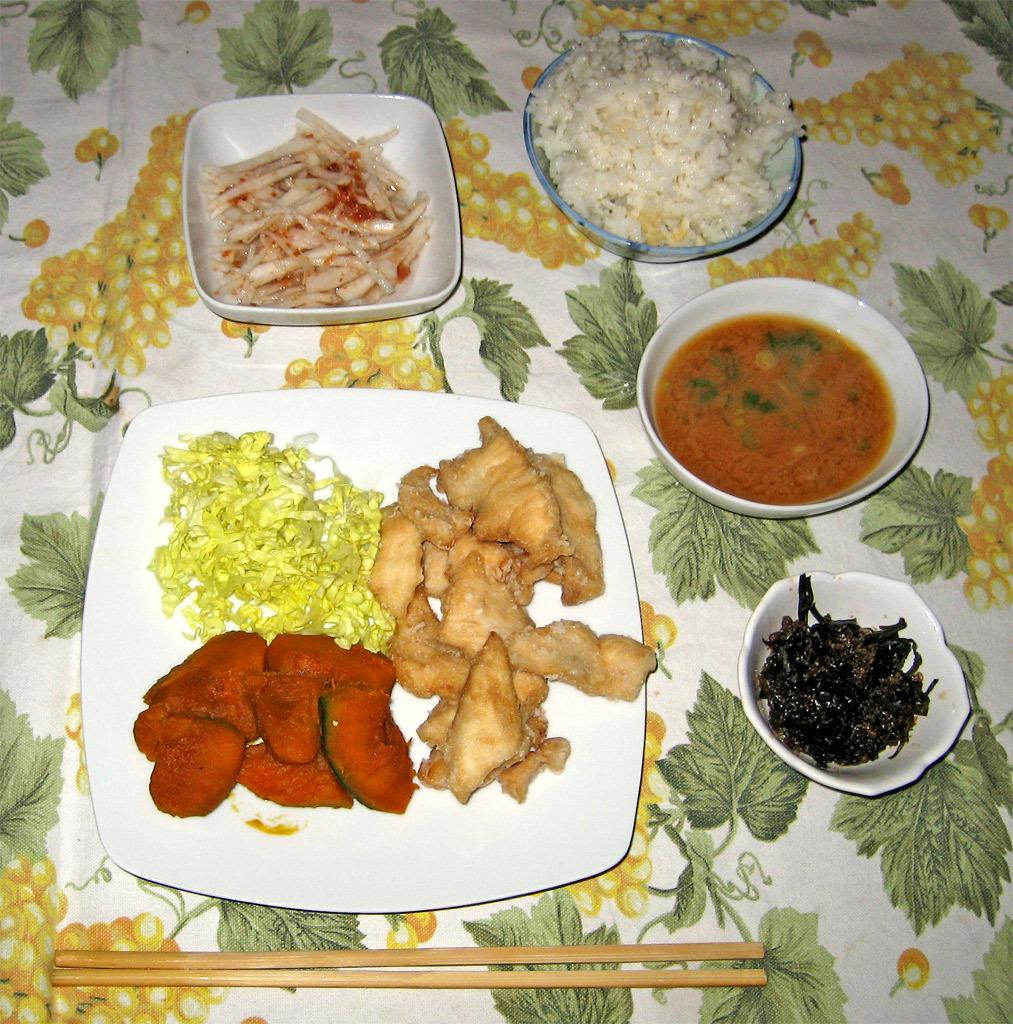What is the main subject in the foreground of the image? There are snack items on a platter in the foreground of the image. What else can be seen around the platter? There are bowls with food in them around the platter. Where are the chopsticks located in the image? Chopsticks are placed on a cloth at the bottom of the image. How many legs can be seen on the snack items in the image? There are no legs visible on the snack items in the image, as they are likely food items without limbs. 